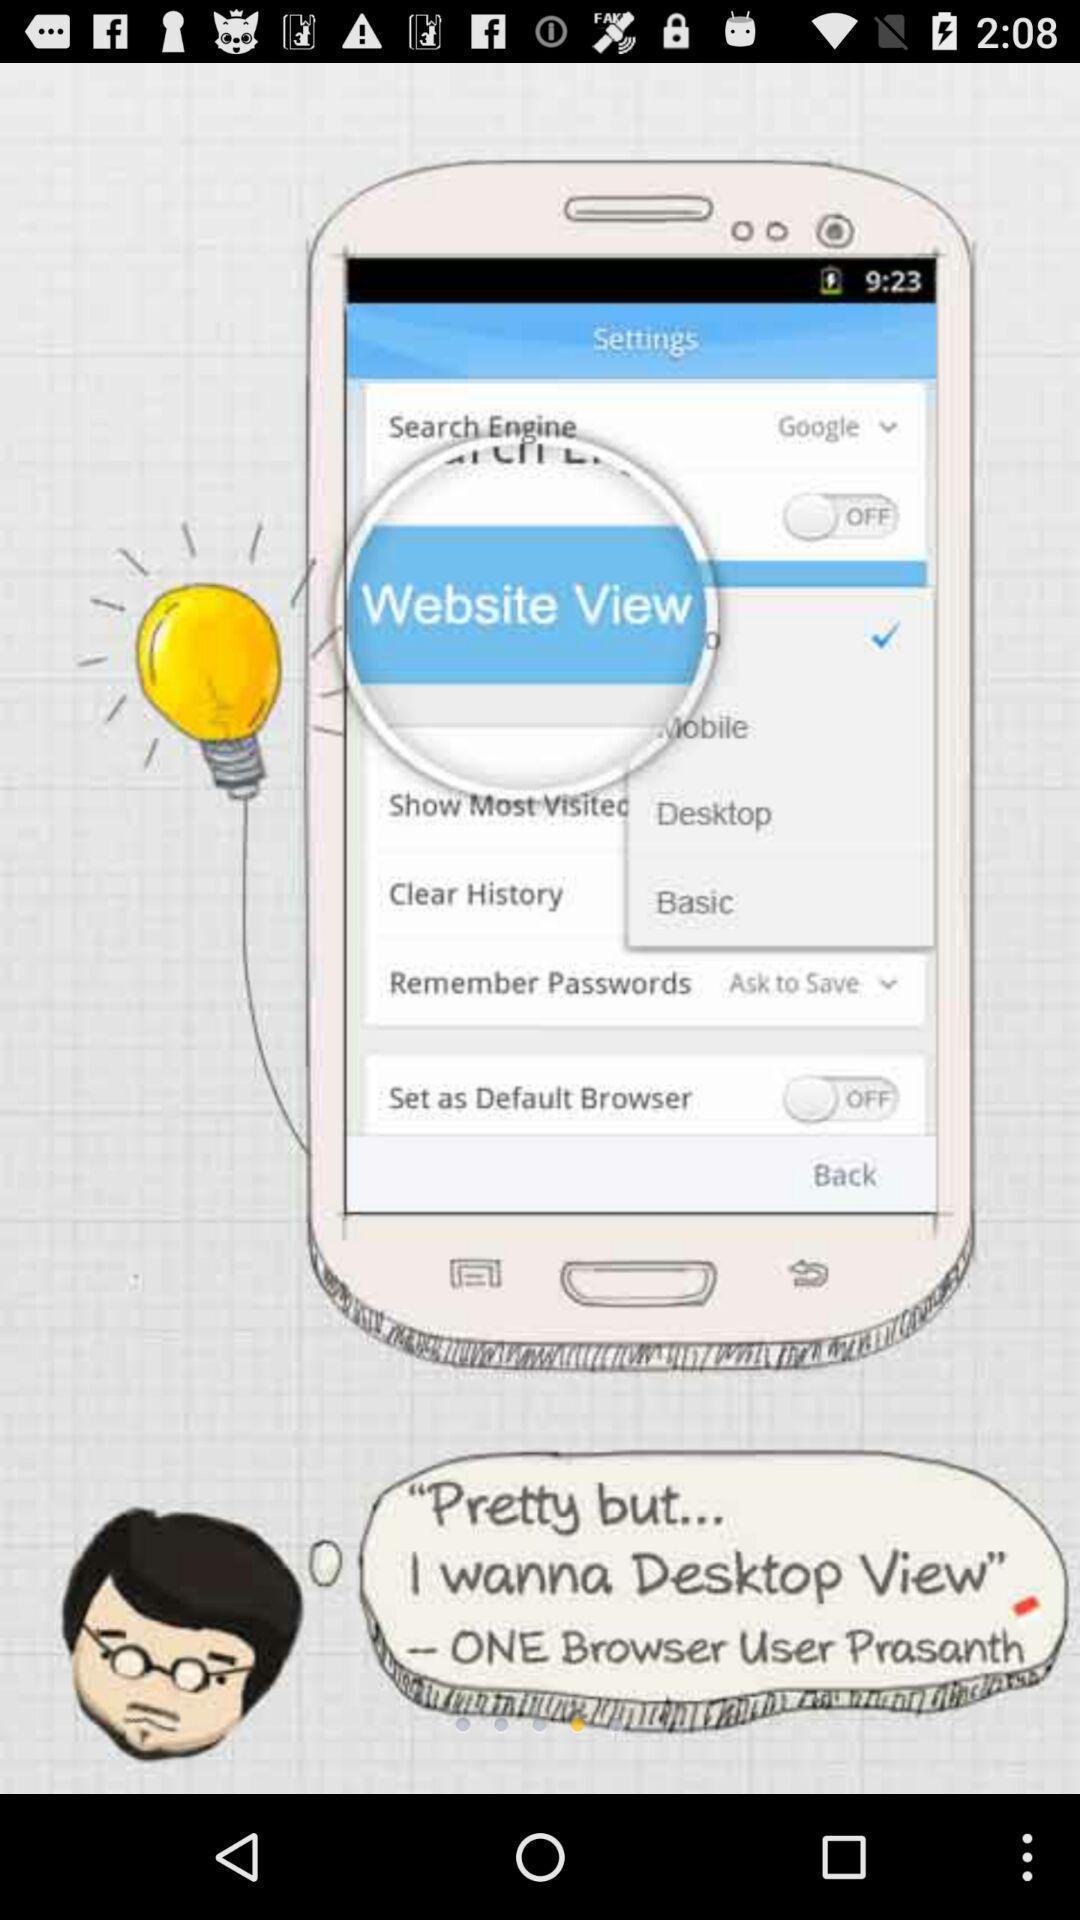Tell me what you see in this picture. Screen shows image of settings option. 